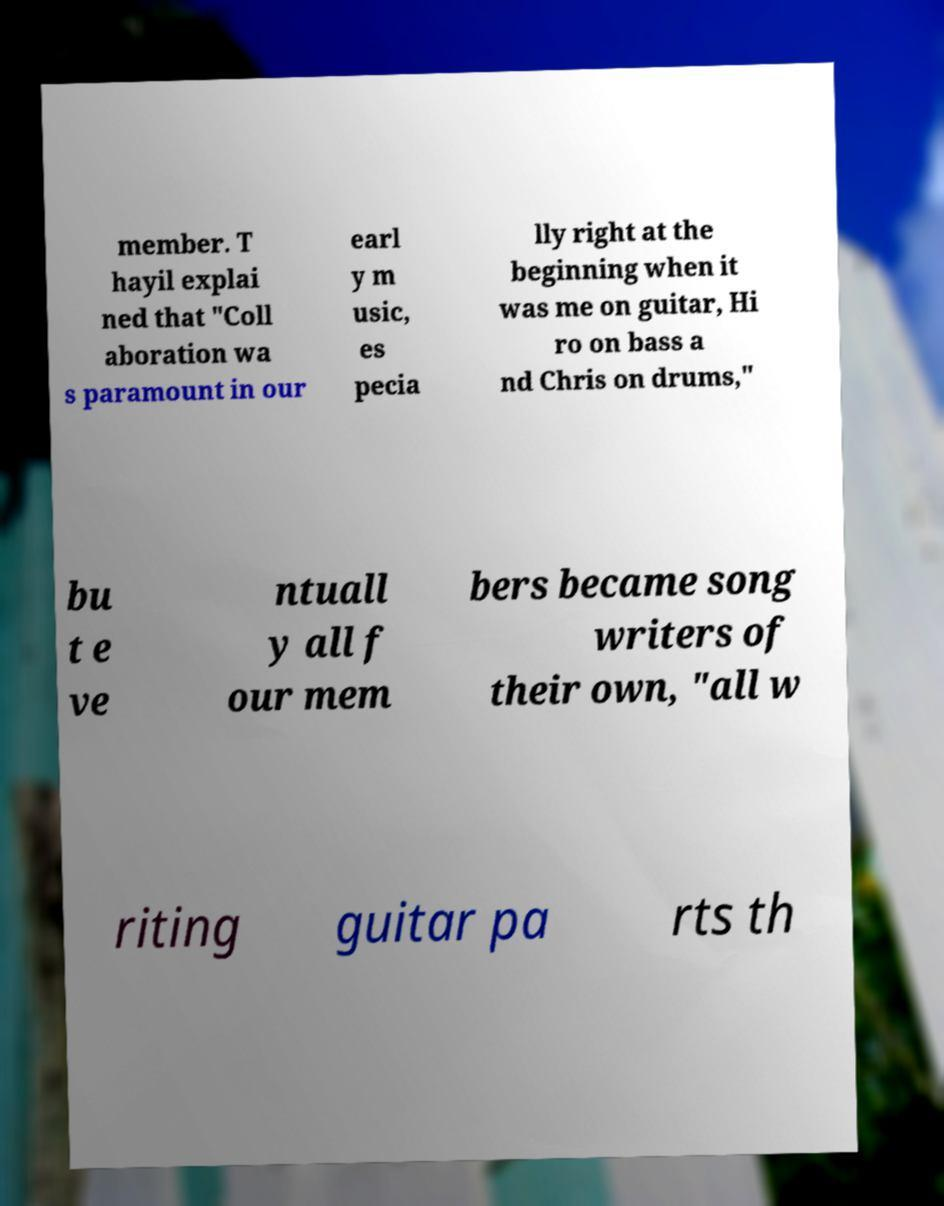What messages or text are displayed in this image? I need them in a readable, typed format. member. T hayil explai ned that "Coll aboration wa s paramount in our earl y m usic, es pecia lly right at the beginning when it was me on guitar, Hi ro on bass a nd Chris on drums," bu t e ve ntuall y all f our mem bers became song writers of their own, "all w riting guitar pa rts th 